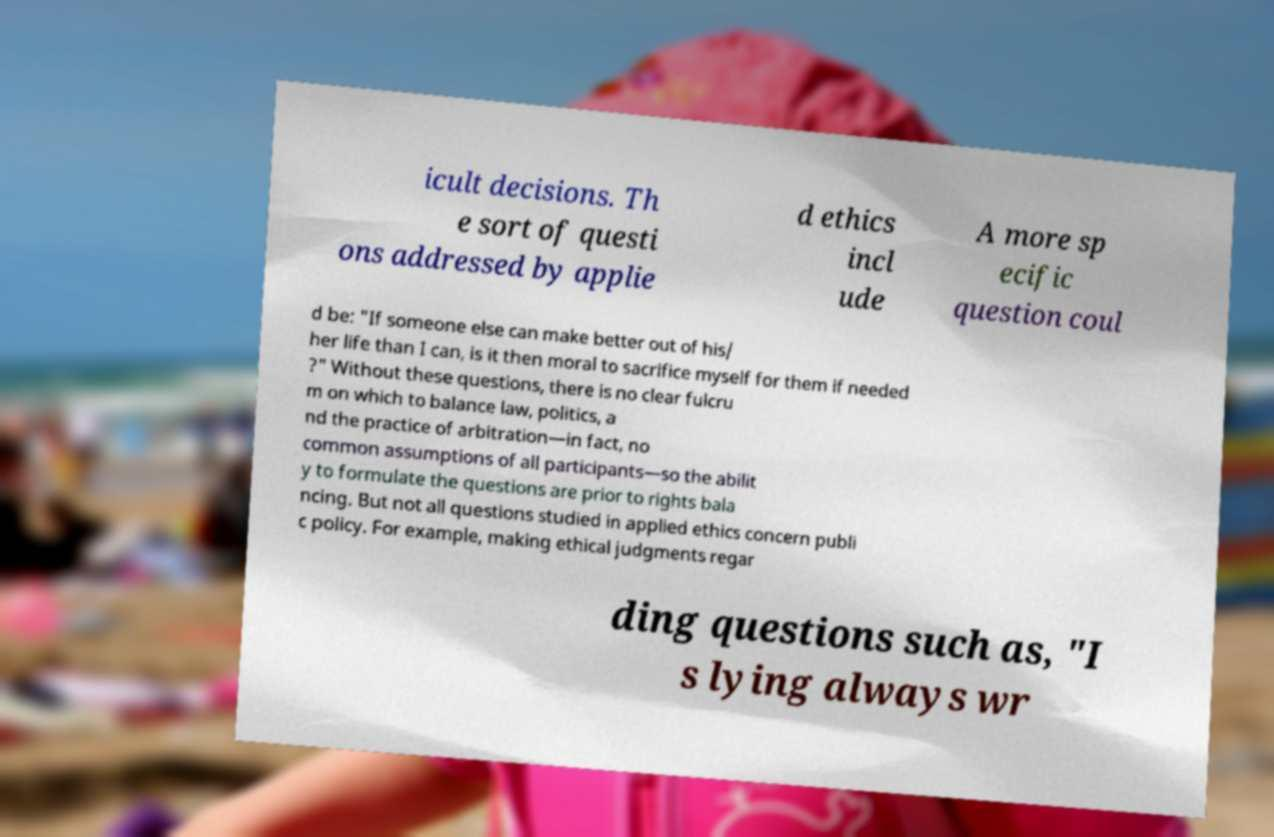What messages or text are displayed in this image? I need them in a readable, typed format. icult decisions. Th e sort of questi ons addressed by applie d ethics incl ude A more sp ecific question coul d be: "If someone else can make better out of his/ her life than I can, is it then moral to sacrifice myself for them if needed ?" Without these questions, there is no clear fulcru m on which to balance law, politics, a nd the practice of arbitration—in fact, no common assumptions of all participants—so the abilit y to formulate the questions are prior to rights bala ncing. But not all questions studied in applied ethics concern publi c policy. For example, making ethical judgments regar ding questions such as, "I s lying always wr 